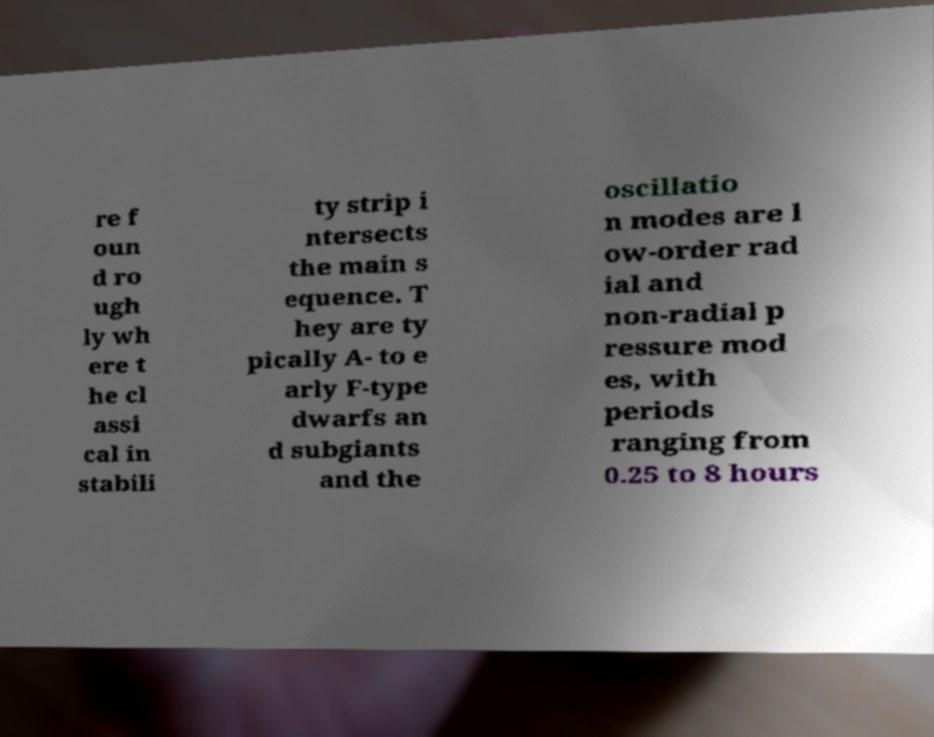There's text embedded in this image that I need extracted. Can you transcribe it verbatim? re f oun d ro ugh ly wh ere t he cl assi cal in stabili ty strip i ntersects the main s equence. T hey are ty pically A- to e arly F-type dwarfs an d subgiants and the oscillatio n modes are l ow-order rad ial and non-radial p ressure mod es, with periods ranging from 0.25 to 8 hours 